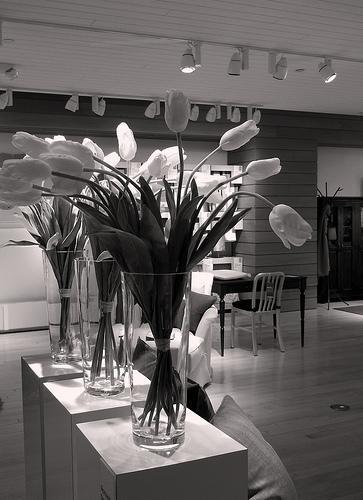How many vases are there?
Give a very brief answer. 3. How many vases?
Give a very brief answer. 3. How many stands for vases?
Give a very brief answer. 3. 